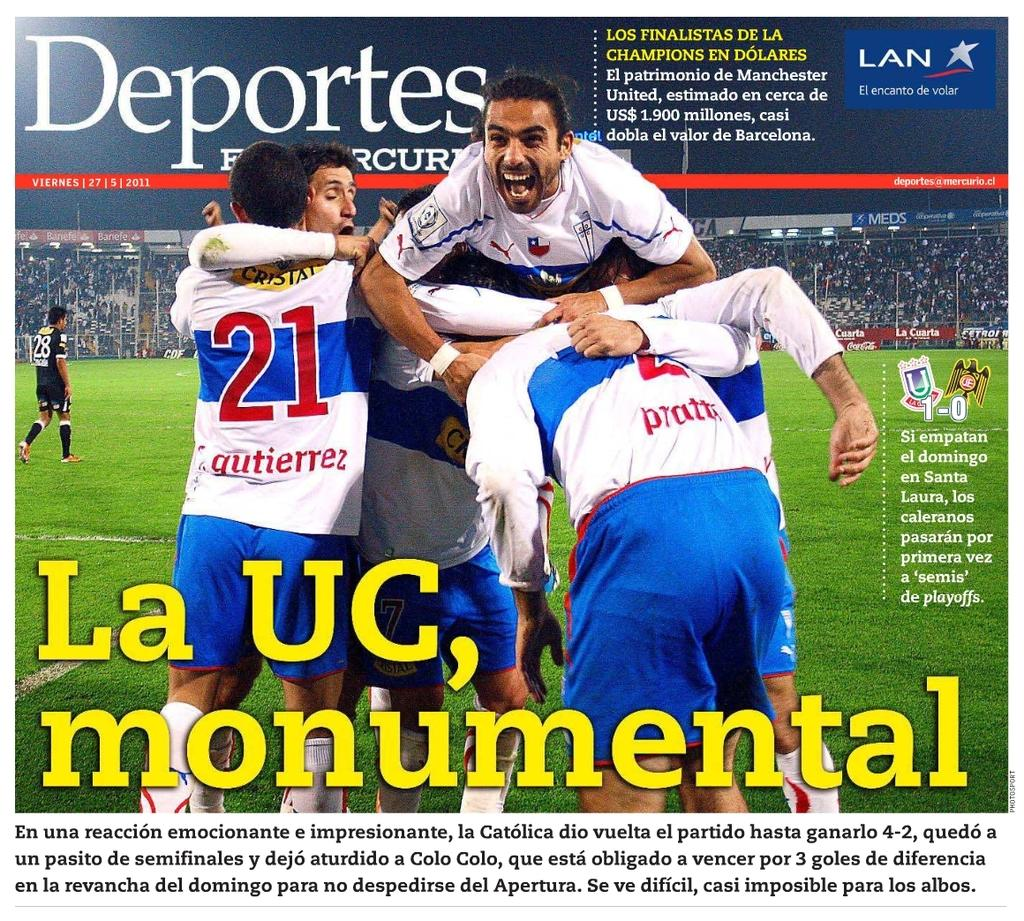<image>
Present a compact description of the photo's key features. The cover of Deportes includes player 21, Gutierrez, celebrating with teammates, "La UC, monumental." 